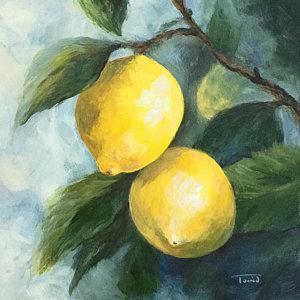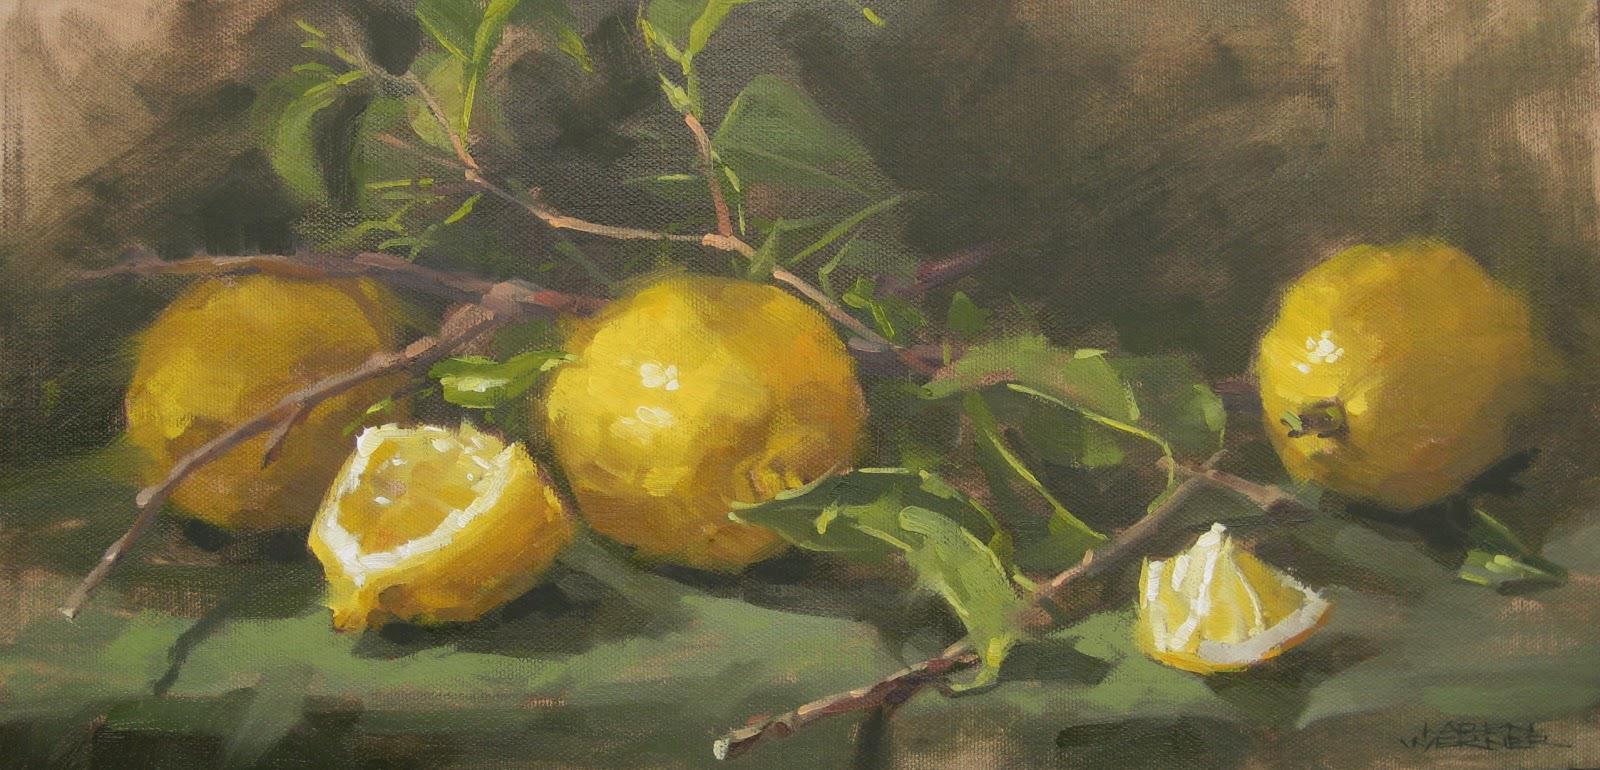The first image is the image on the left, the second image is the image on the right. Evaluate the accuracy of this statement regarding the images: "There are 6 lemons". Is it true? Answer yes or no. No. 